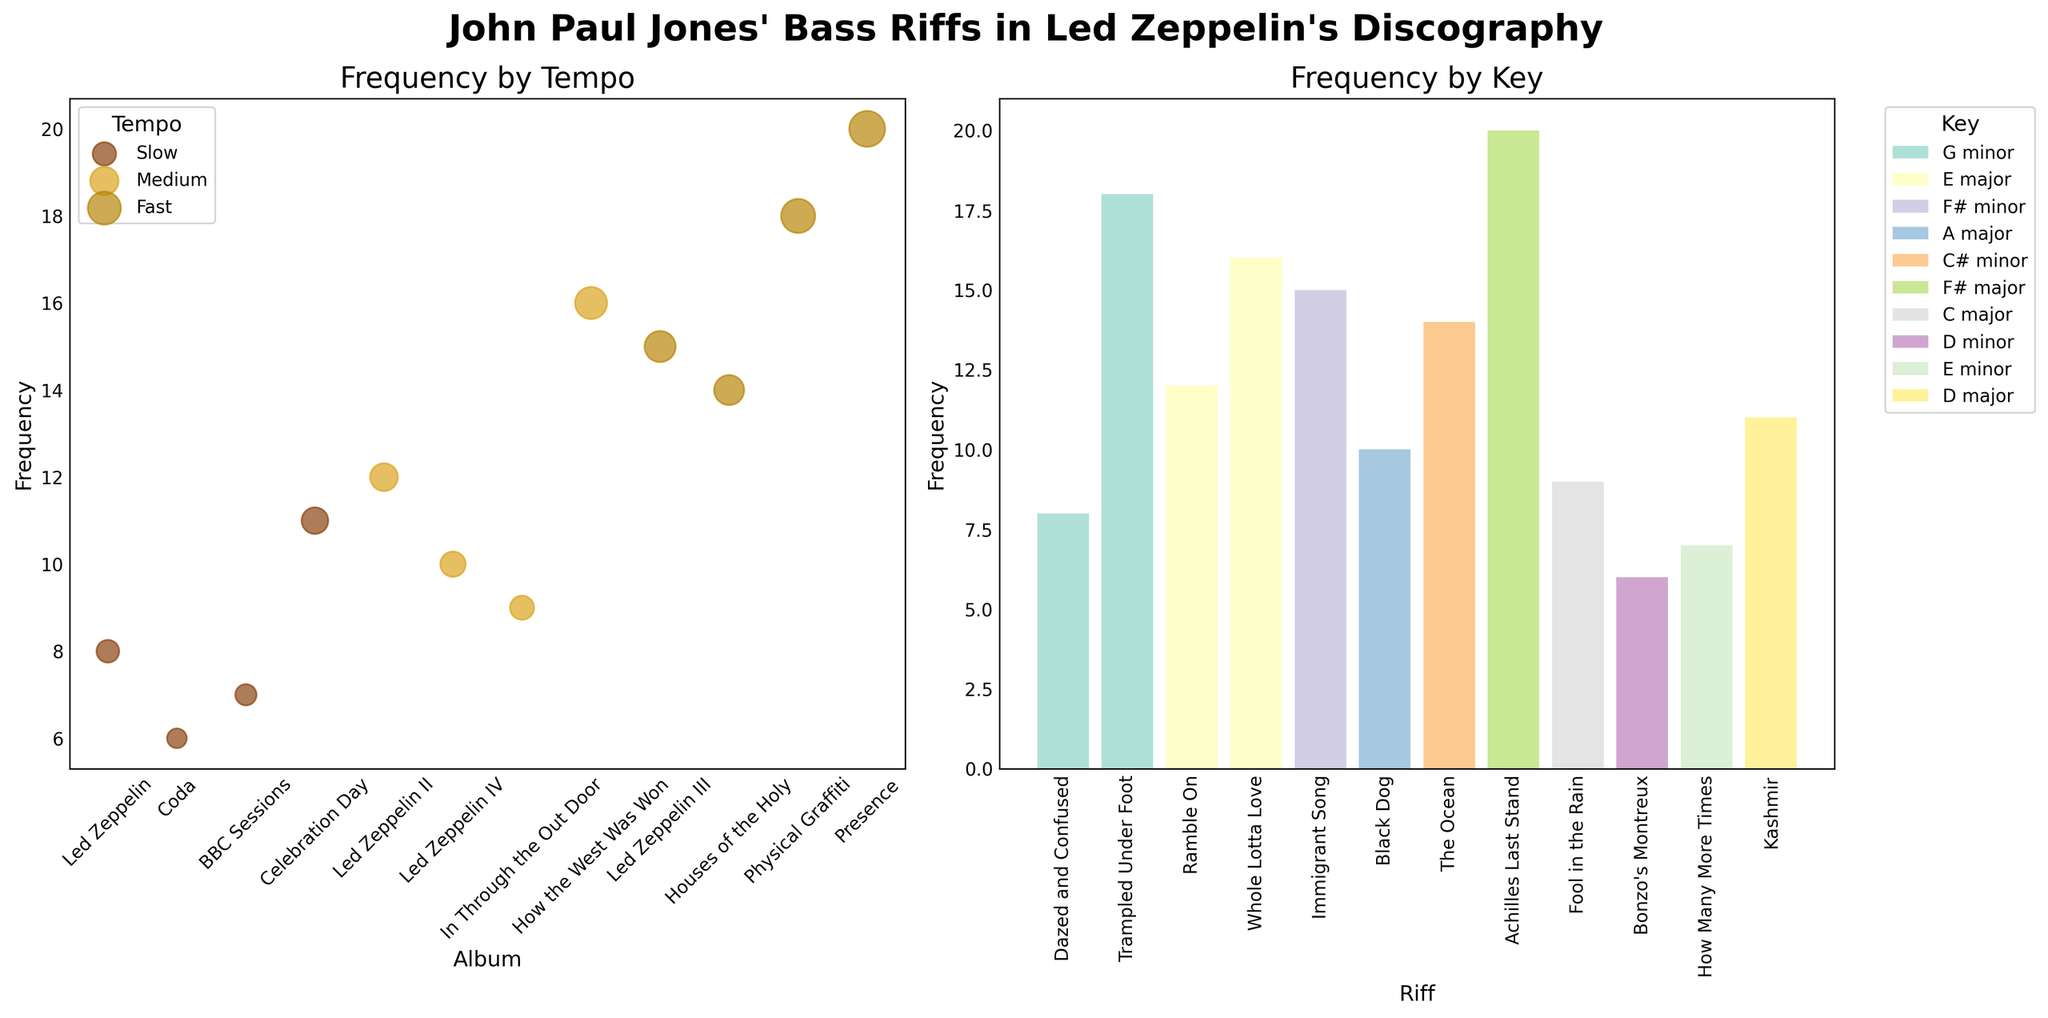What is the title of the figure? The title of a figure is typically located at the top of the figure. In this case, it is printed in bold and large fonts.
Answer: John Paul Jones' Bass Riffs in Led Zeppelin's Discography How many different keys are represented in the Frequency by Key subplot? By counting the different colors and corresponding key labels in the legend, you can determine the number of unique keys.
Answer: 8 Which album has the highest frequency of bass riffs for a "Fast" tempo? In the Frequency by Tempo subplot, observe the size of the bubbles for "Fast" tempos; the largest bubble indicates the highest frequency.
Answer: Presence Which riff has the highest frequency regardless of the key in the Frequency by Key subplot? The highest bar in the subplot represents the riff with the highest frequency.
Answer: Achilles Last Stand What is the total frequency of bass riffs for "Medium" tempo across all albums? Sum the frequencies associated with "Medium" tempo bass riffs from the Frequency by Tempo subplot.
Answer: 47 Which key has the fewest riffs and how many does it have? Identify the shortest bar in the Frequency by Key subplot and check its label in the legend to find out which key it represents.
Answer: D minor, 6 Compare the frequencies of "Slow" and "Fast" tempos in the 'Led Zeppelin' album. Which one is higher and by how much? In the Frequency by Tempo subplot, compare the sizes of bubbles for "Slow" and "Fast" tempos. Calculate the difference between the frequencies.
Answer: Slow by 1 What is the average frequency of bass riffs for the “Fast” tempo across all albums? Sum the frequencies for all "Fast" tempos and divide by the number of albums with "Fast" tempo bass riffs.
Answer: 16.75 How many riffs are played in the E major key, and how many of those are from a "Medium" tempo? Look at the Frequency by Key subplot for bars labeled with E major to sum their frequencies. Then, refer to the legend in the Frequency by Tempo subplot to identify bars associated with "Medium" tempo that are within the E major key.
Answer: 28, 28 What is the difference in the number of riffs between the riff with the highest frequency and the riff with the lowest frequency? Identify the highest and lowest bars in the Frequency by Key subplot to find their frequencies, then subtract the frequency of the lowest from the highest.
Answer: 14 